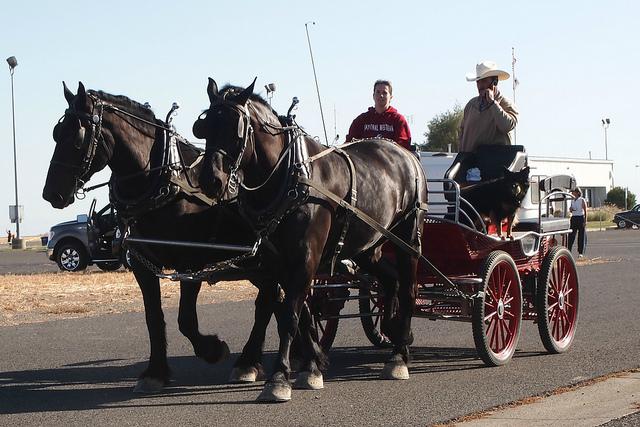What are the horses pulling?
Short answer required. Wagon. How many horses are in the photo?
Concise answer only. 2. How many horses are pulling the carriage?
Write a very short answer. 2. How many horses are there?
Be succinct. 2. Which horse is taller?
Keep it brief. Left one. What is riding with the man in the carriage?
Short answer required. Man. How many people are in the carriage?
Short answer required. 2. What kind of horses are these?
Write a very short answer. Stallion. What is the name of the item that the two horses are pulling?
Answer briefly. Carriage. Are the men in the carriage wearing formal clothes?
Give a very brief answer. No. How many horses are in this picture?
Quick response, please. 2. Is anyone riding a bicycle?
Quick response, please. No. What kind of animals are shown?
Answer briefly. Horses. Who else is in the carriage?
Quick response, please. Man. Is any of the concrete broken?
Quick response, please. No. How many horses?
Concise answer only. 2. 